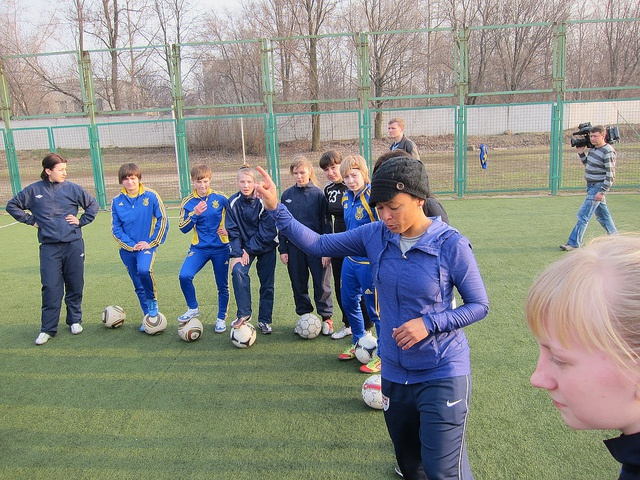Describe the objects in this image and their specific colors. I can see people in white, navy, blue, and black tones, people in white, lightpink, darkgray, tan, and gray tones, people in white, navy, gray, and darkblue tones, people in white, black, navy, gray, and darkgray tones, and people in white, navy, black, darkblue, and lightpink tones in this image. 